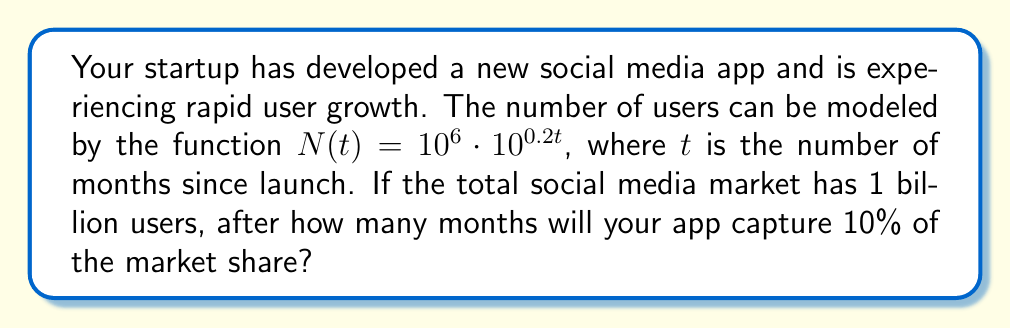Show me your answer to this math problem. Let's approach this step-by-step:

1) We need to find $t$ when $N(t)$ equals 10% of 1 billion users.

2) 10% of 1 billion is $0.1 \cdot 10^9 = 10^8$ users.

3) So, we need to solve the equation:
   $10^6 \cdot 10^{0.2t} = 10^8$

4) Let's apply logarithms (base 10) to both sides:
   $\log(10^6 \cdot 10^{0.2t}) = \log(10^8)$

5) Using the logarithm property $\log(a \cdot b) = \log(a) + \log(b)$:
   $\log(10^6) + \log(10^{0.2t}) = 8$

6) Simplify:
   $6 + 0.2t = 8$

7) Subtract 6 from both sides:
   $0.2t = 2$

8) Divide both sides by 0.2:
   $t = 2 / 0.2 = 10$

Therefore, the app will capture 10% of the market share after 10 months.
Answer: 10 months 